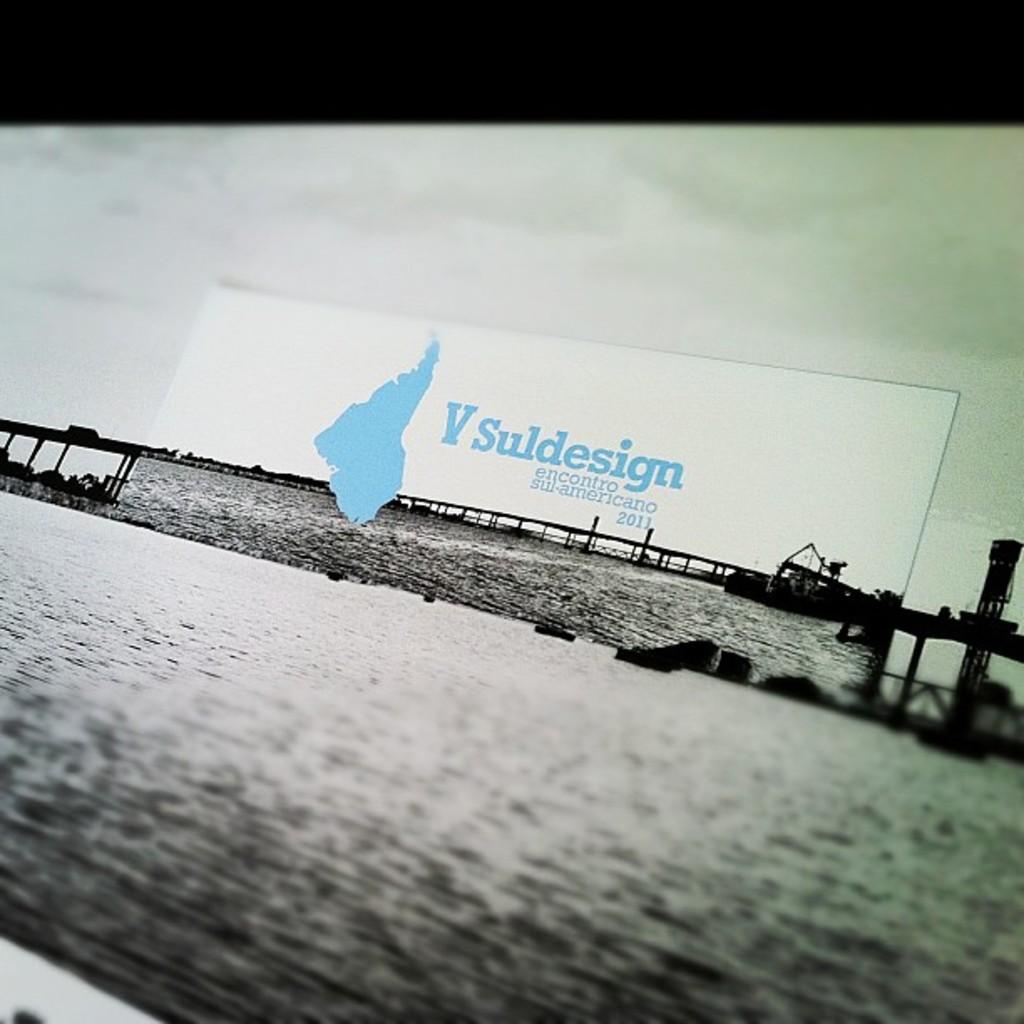What year is mentioned in the sign?
Your answer should be very brief. 2011. What is the title on this billboard?
Ensure brevity in your answer.  V suldesign. 